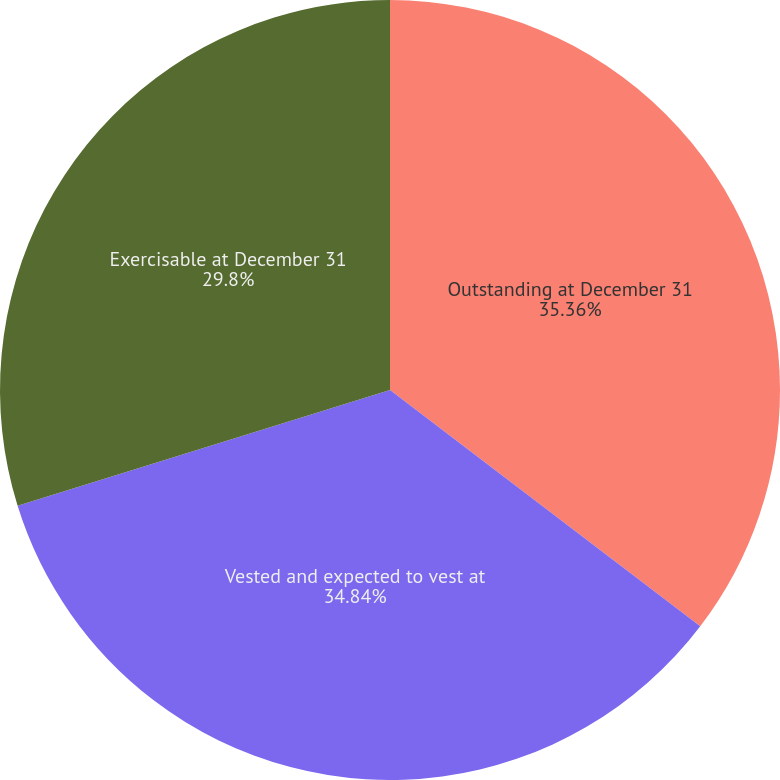Convert chart. <chart><loc_0><loc_0><loc_500><loc_500><pie_chart><fcel>Outstanding at December 31<fcel>Vested and expected to vest at<fcel>Exercisable at December 31<nl><fcel>35.36%<fcel>34.84%<fcel>29.8%<nl></chart> 